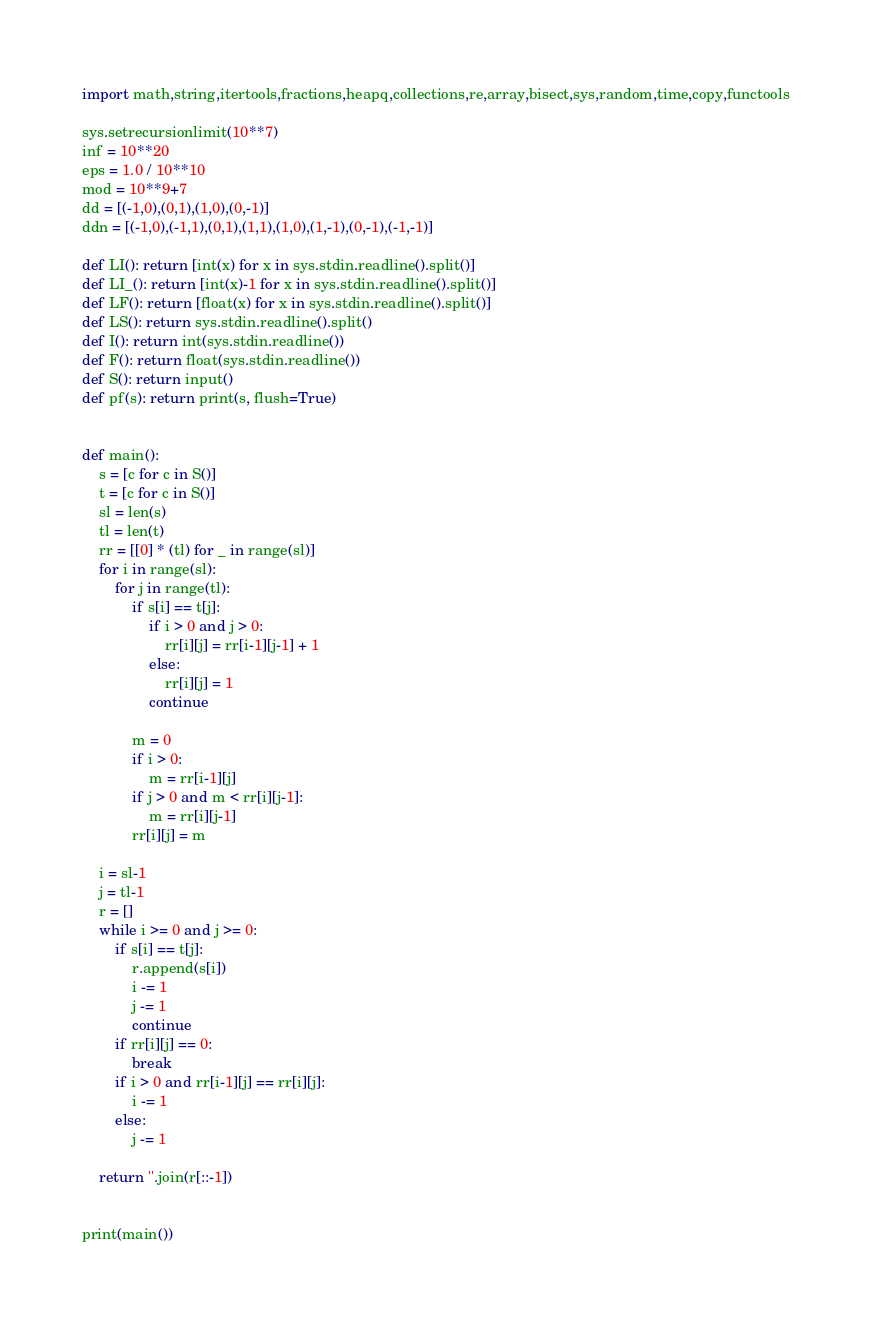<code> <loc_0><loc_0><loc_500><loc_500><_Python_>import math,string,itertools,fractions,heapq,collections,re,array,bisect,sys,random,time,copy,functools

sys.setrecursionlimit(10**7)
inf = 10**20
eps = 1.0 / 10**10
mod = 10**9+7
dd = [(-1,0),(0,1),(1,0),(0,-1)]
ddn = [(-1,0),(-1,1),(0,1),(1,1),(1,0),(1,-1),(0,-1),(-1,-1)]

def LI(): return [int(x) for x in sys.stdin.readline().split()]
def LI_(): return [int(x)-1 for x in sys.stdin.readline().split()]
def LF(): return [float(x) for x in sys.stdin.readline().split()]
def LS(): return sys.stdin.readline().split()
def I(): return int(sys.stdin.readline())
def F(): return float(sys.stdin.readline())
def S(): return input()
def pf(s): return print(s, flush=True)


def main():
    s = [c for c in S()]
    t = [c for c in S()]
    sl = len(s)
    tl = len(t)
    rr = [[0] * (tl) for _ in range(sl)]
    for i in range(sl):
        for j in range(tl):
            if s[i] == t[j]:
                if i > 0 and j > 0:
                    rr[i][j] = rr[i-1][j-1] + 1
                else:
                    rr[i][j] = 1
                continue

            m = 0
            if i > 0:
                m = rr[i-1][j]
            if j > 0 and m < rr[i][j-1]:
                m = rr[i][j-1]
            rr[i][j] = m

    i = sl-1
    j = tl-1
    r = []
    while i >= 0 and j >= 0:
        if s[i] == t[j]:
            r.append(s[i])
            i -= 1
            j -= 1
            continue
        if rr[i][j] == 0:
            break
        if i > 0 and rr[i-1][j] == rr[i][j]:
            i -= 1
        else:
            j -= 1

    return ''.join(r[::-1])


print(main())
</code> 